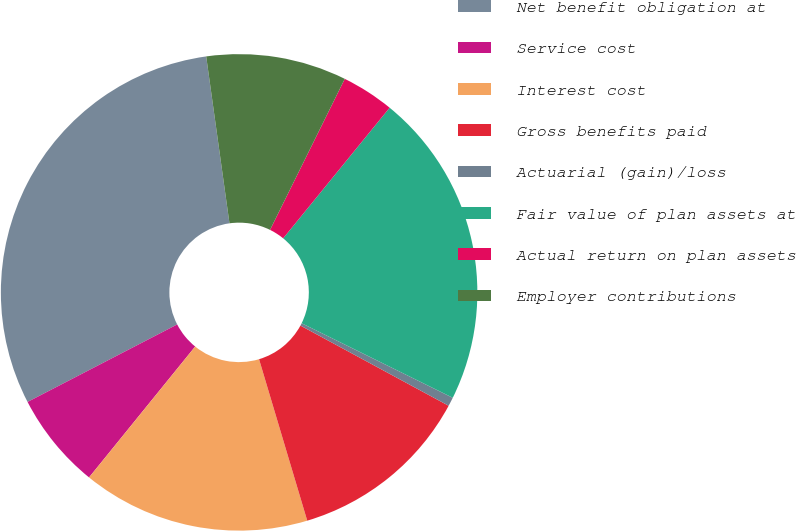<chart> <loc_0><loc_0><loc_500><loc_500><pie_chart><fcel>Net benefit obligation at<fcel>Service cost<fcel>Interest cost<fcel>Gross benefits paid<fcel>Actuarial (gain)/loss<fcel>Fair value of plan assets at<fcel>Actual return on plan assets<fcel>Employer contributions<nl><fcel>30.4%<fcel>6.55%<fcel>15.46%<fcel>12.49%<fcel>0.6%<fcel>21.41%<fcel>3.57%<fcel>9.52%<nl></chart> 